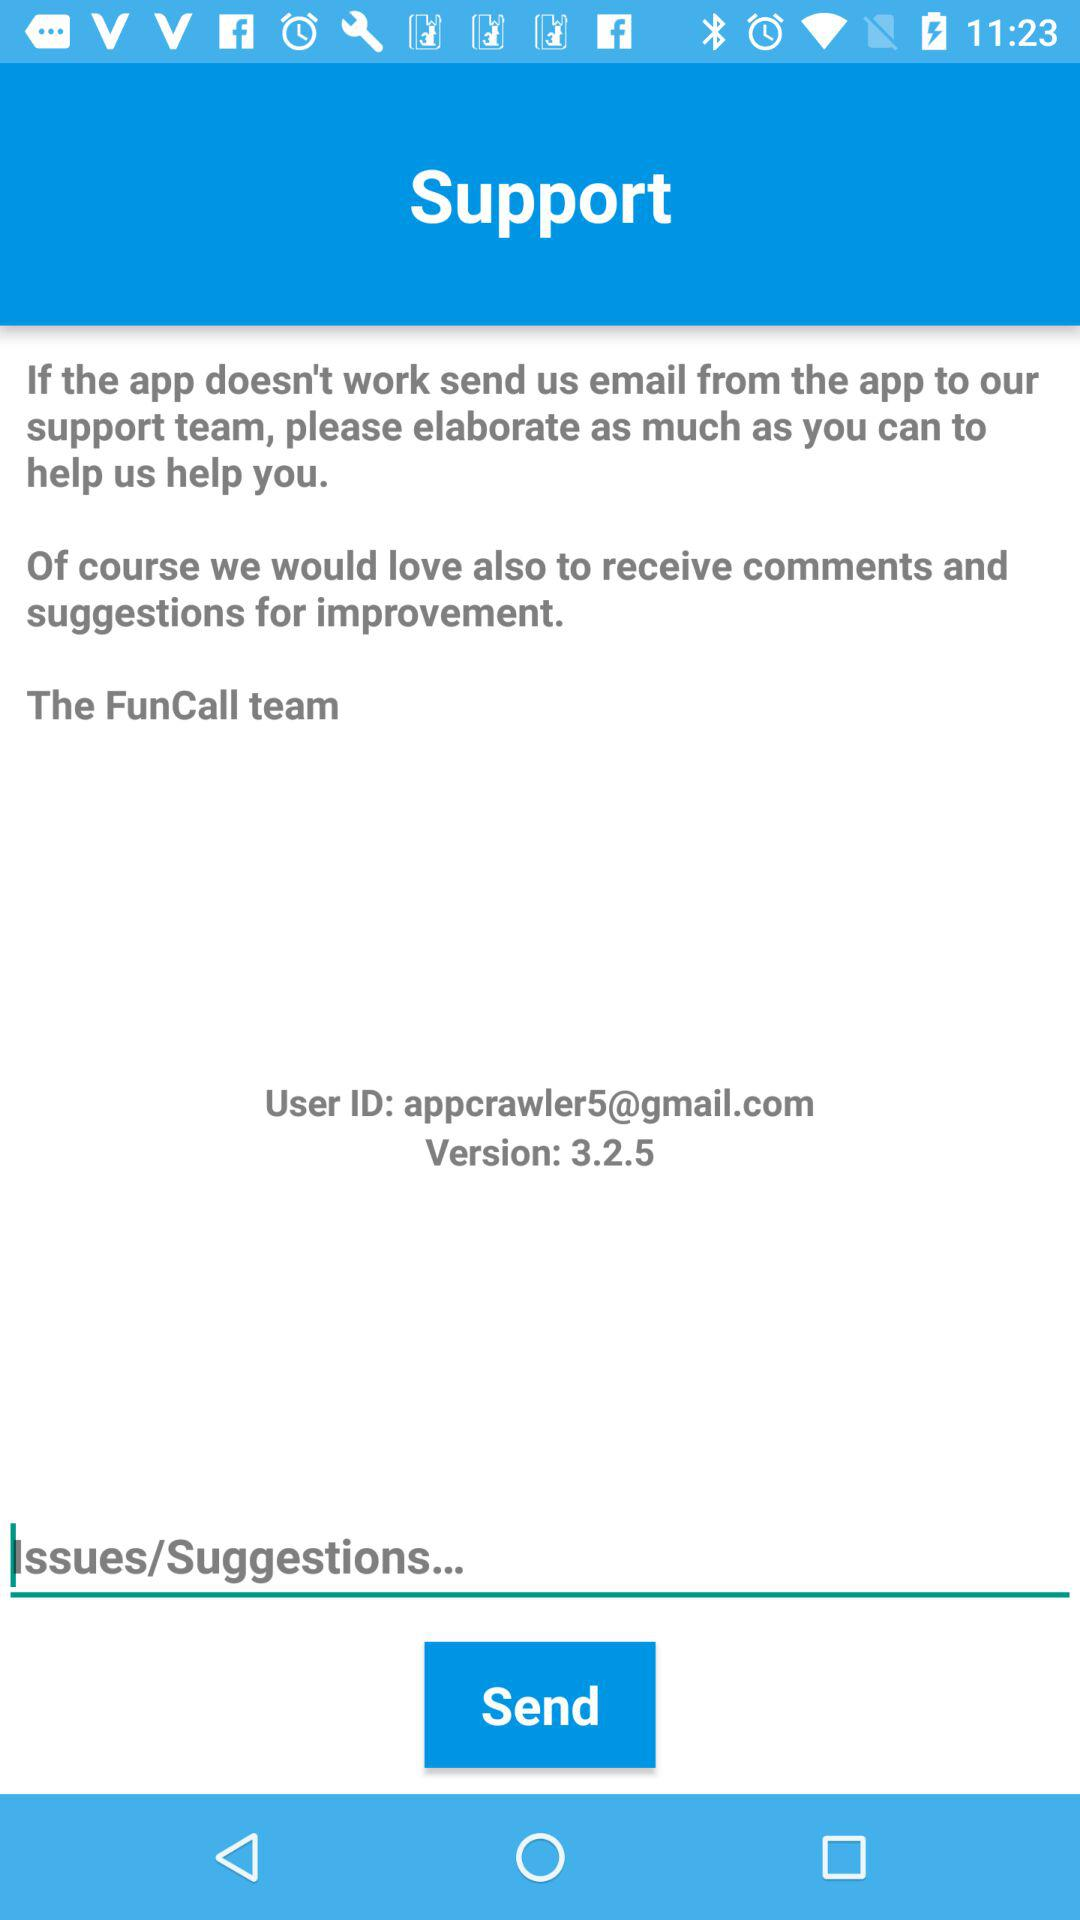What is the version? The version is 3.2.5. 